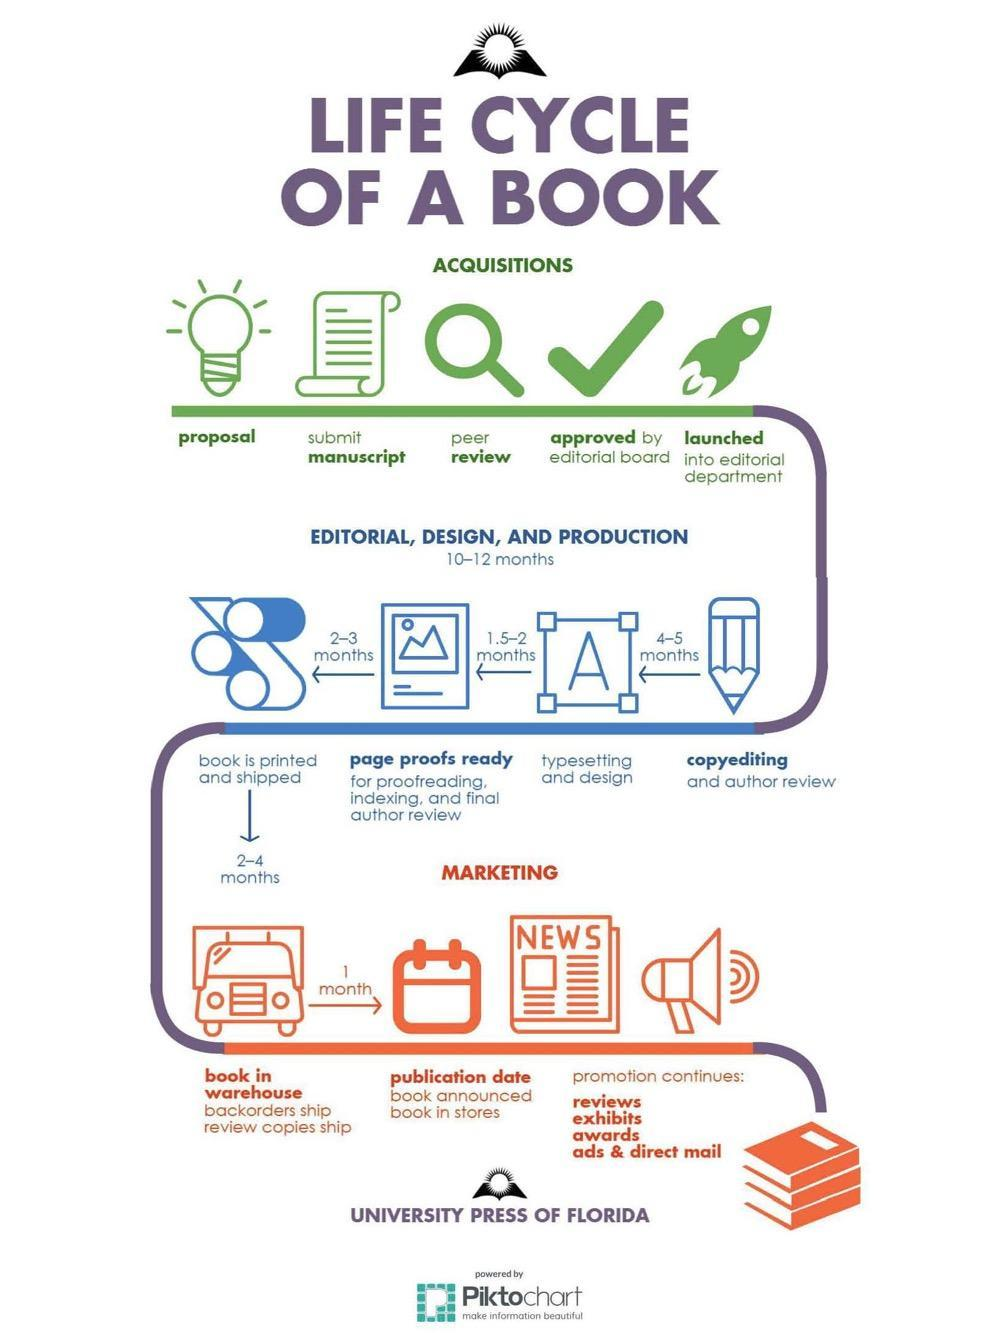Which is the third step in Acquisitions?
Answer the question with a short phrase. peer review How much time does it take from copyediting to typesetting and design? 4-5 months 